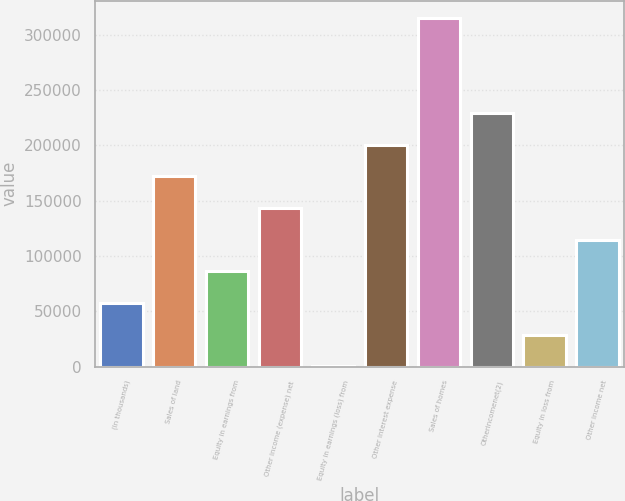<chart> <loc_0><loc_0><loc_500><loc_500><bar_chart><fcel>(In thousands)<fcel>Sales of land<fcel>Equity in earnings from<fcel>Other income (expense) net<fcel>Equity in earnings (loss) from<fcel>Other interest expense<fcel>Sales of homes<fcel>Otherincomenet(2)<fcel>Equity in loss from<fcel>Other income net<nl><fcel>57383.4<fcel>171888<fcel>86009.6<fcel>143262<fcel>131<fcel>200514<fcel>315019<fcel>229141<fcel>28757.2<fcel>114636<nl></chart> 